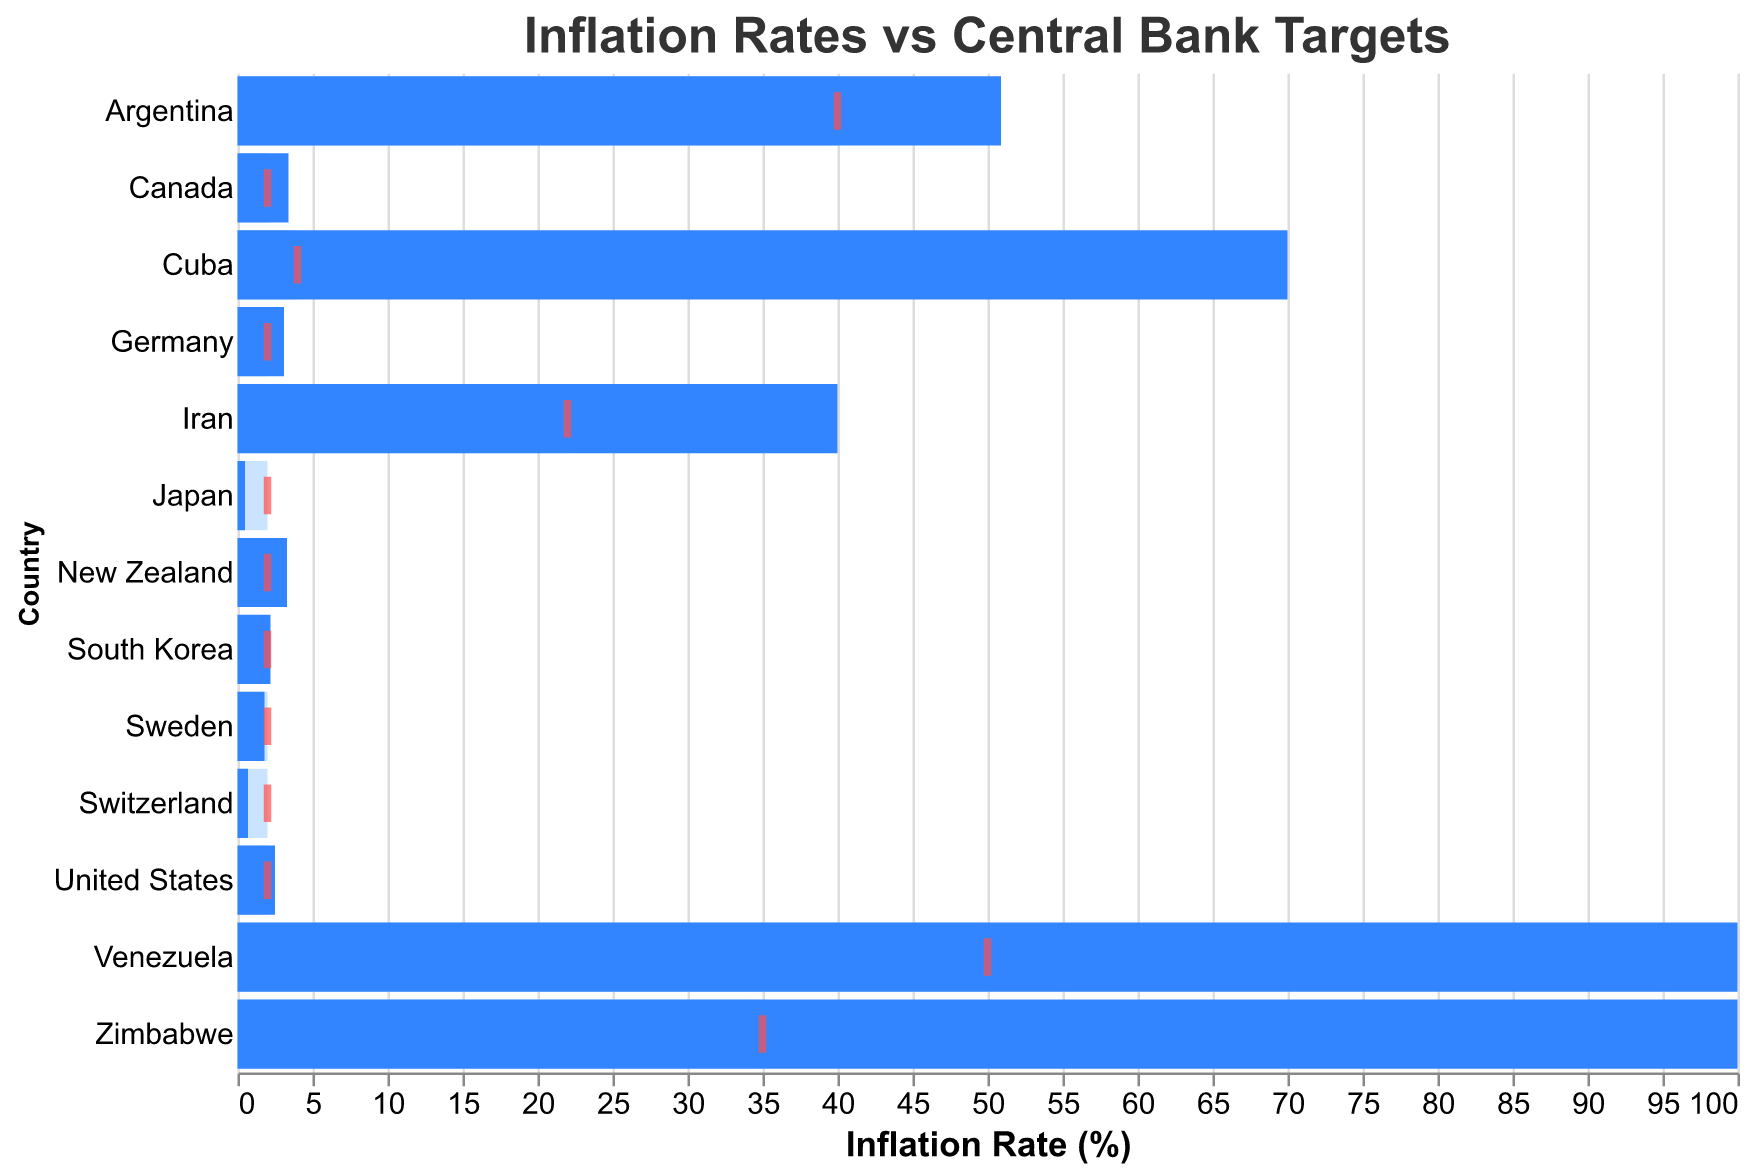Which country has the highest inflation rate? The bar corresponding to Venezuela extends up to about 2700% on the inflation rate axis, indicating it has the highest inflation rate among the listed countries.
Answer: Venezuela What is the central bank's target for inflation in Japan? The red tick mark for Japan is positioned at 2.0% on the axis, which indicates the central bank's target for inflation.
Answer: 2.0% How does Venezuela's inflation rate compare to its central bank's target? The inflation rate bar for Venezuela extends to 2700%, while the target is indicated at 50%. This shows Venezuela's inflation rate far exceeds its central bank's target.
Answer: Inflation rate exceeds target by 2650% What is the difference between Iran's inflation rate and its central bank target? Iran's inflation rate is shown at 40%, and the red tick mark shows the target at 22%. The difference can be calculated as 40% - 22% = 18%.
Answer: 18% Which country is closest to meeting its central bank's target? By observing which blue bar is closest to its corresponding red tick mark, Japan (0.5% vs 2.0%) seems closest to its target among the countries listed.
Answer: Japan Which countries have price controls and how do their inflation rates compare to their targets? Observing countries with "Yes" in the 'Price Controls' column: Venezuela (2700% vs 50%), Argentina (50.9% vs 40%), Zimbabwe (285% vs 35%), Iran (40% vs 22%), and Cuba (70% vs 4%) all have much higher inflation rates compared to their targets.
Answer: All have much higher inflation rates How many countries in the chart have inflation rates that exceed 100%? The infographic has capped some inflation rates at 100% for visual clarity, meaning countries like Venezuela, Zimbabwe, and Cuba exceed 100%.
Answer: 3 Which country has an inflation rate closest to 2.0%? Examining the lengths of the blue bars, South Korea (2.2%) and the United States (2.5%) have inflation rates closest to 2.0%, with South Korea being slightly closer.
Answer: South Korea How does Canada's inflation rate compare to Germany's? Canada's inflation rate is indicated at 3.4%, while Germany's is at 3.1%. Comparing these values directly, Canada's rate is higher by 0.3%.
Answer: Canada is higher What is the average central bank target for all countries listed? Adding all the target values: 2 + 50 + 2 + 2 + 40 + 2 + 35 + 2 + 2 + 2 + 22 + 2 + 4 = 167. Dividing this by 13 gives the average: 167 / 13 ≈ 12.85%.
Answer: ≈ 12.85% 